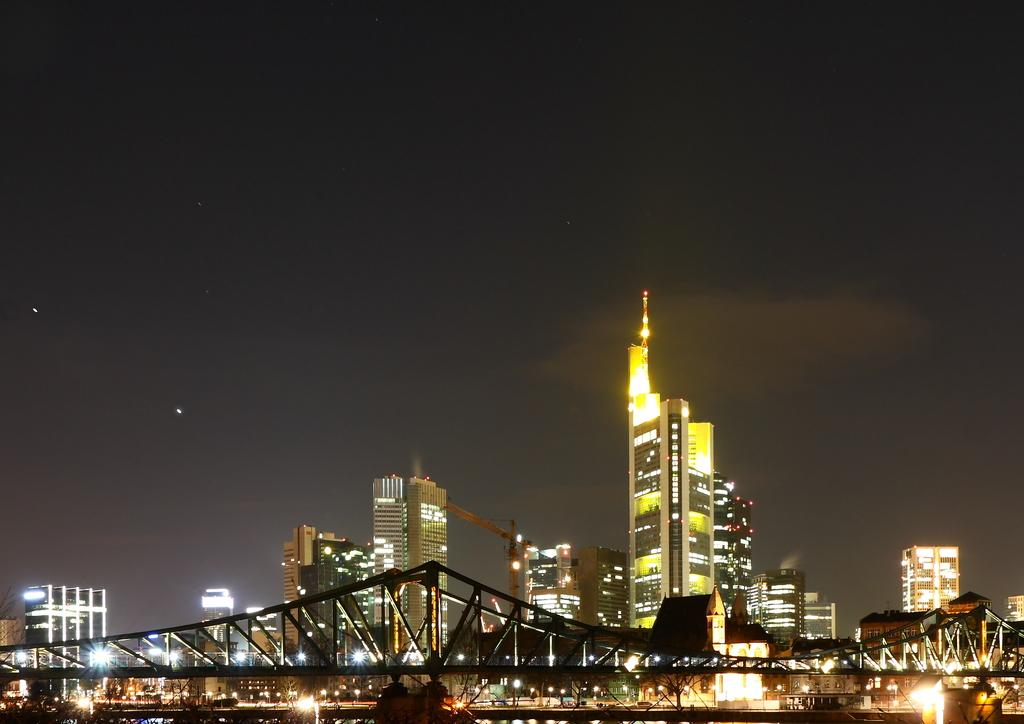What type of structures can be seen in the image? There are many buildings in the image. Is there any specific architectural feature in the image? Yes, there is a bridge in the image. What other elements can be seen in the image? There is a fence, lights, and a tower in the image. What is visible in the background of the image? The sky is visible in the image. Can you see an umbrella being used by someone in the image? There is no umbrella present in the image. What type of current is flowing under the bridge in the image? There is no indication of a current or water body in the image, as it only shows a bridge, buildings, and other structures. 